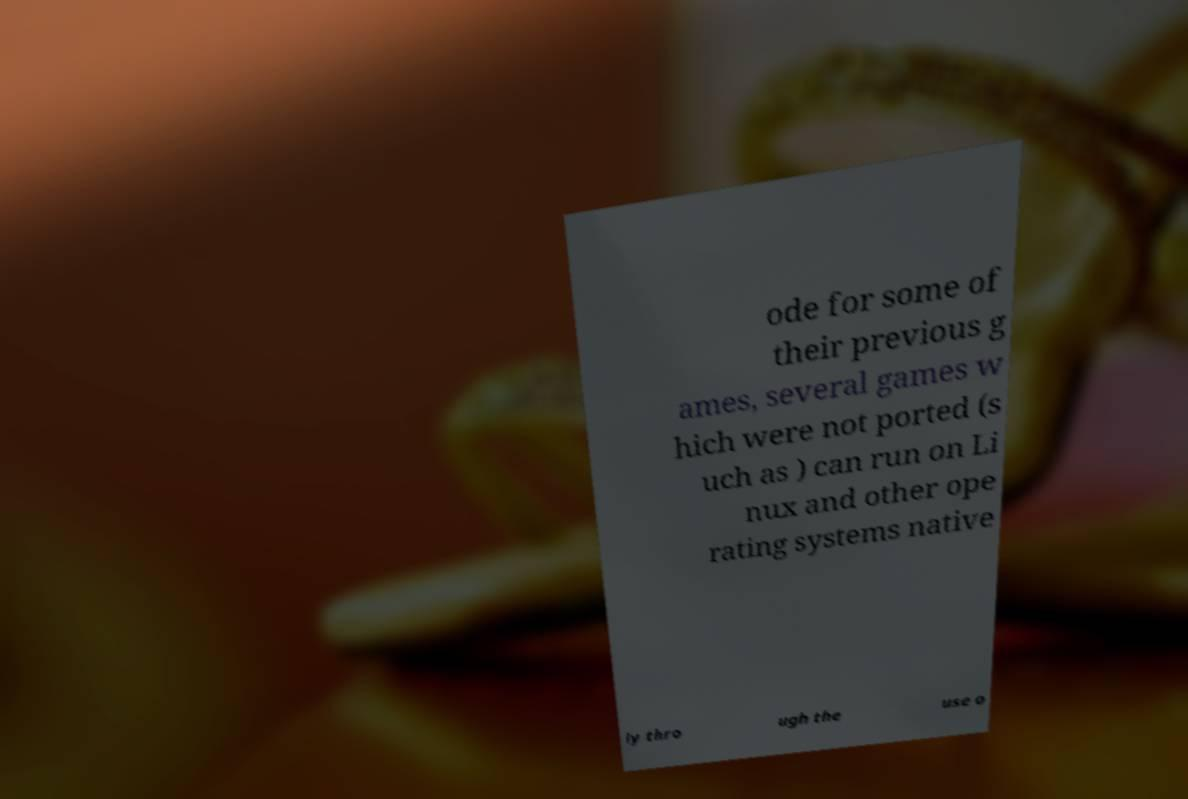Could you assist in decoding the text presented in this image and type it out clearly? ode for some of their previous g ames, several games w hich were not ported (s uch as ) can run on Li nux and other ope rating systems native ly thro ugh the use o 